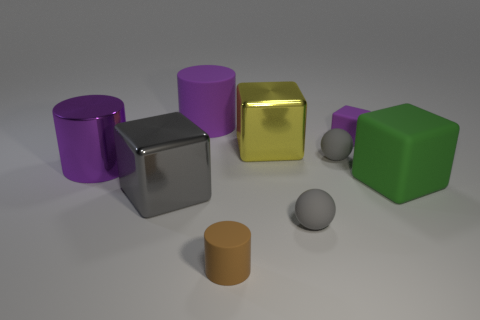Subtract all large purple cylinders. How many cylinders are left? 1 Subtract all balls. How many objects are left? 7 Add 4 large purple matte cylinders. How many large purple matte cylinders exist? 5 Subtract all yellow cubes. How many cubes are left? 3 Subtract 1 brown cylinders. How many objects are left? 8 Subtract 2 cubes. How many cubes are left? 2 Subtract all green cubes. Subtract all blue cylinders. How many cubes are left? 3 Subtract all yellow cylinders. How many gray cubes are left? 1 Subtract all small objects. Subtract all metallic spheres. How many objects are left? 5 Add 3 small gray objects. How many small gray objects are left? 5 